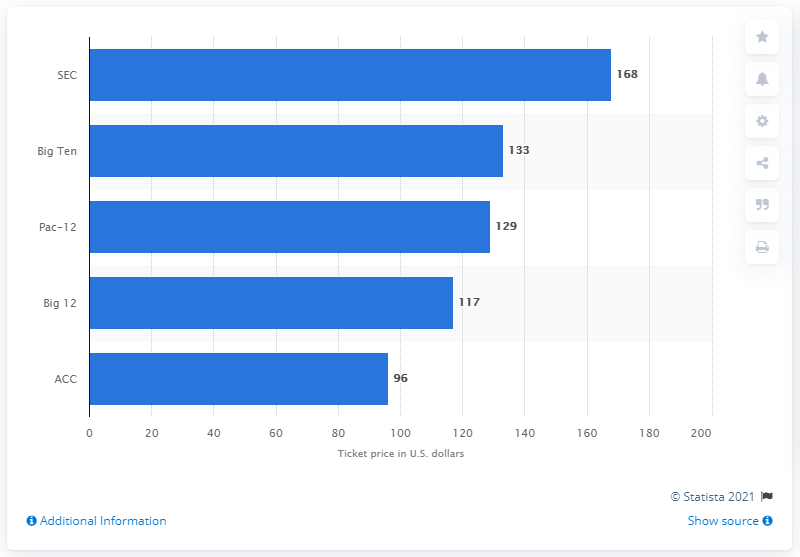List a handful of essential elements in this visual. The average cost of attending a SEC football game is approximately $168. 